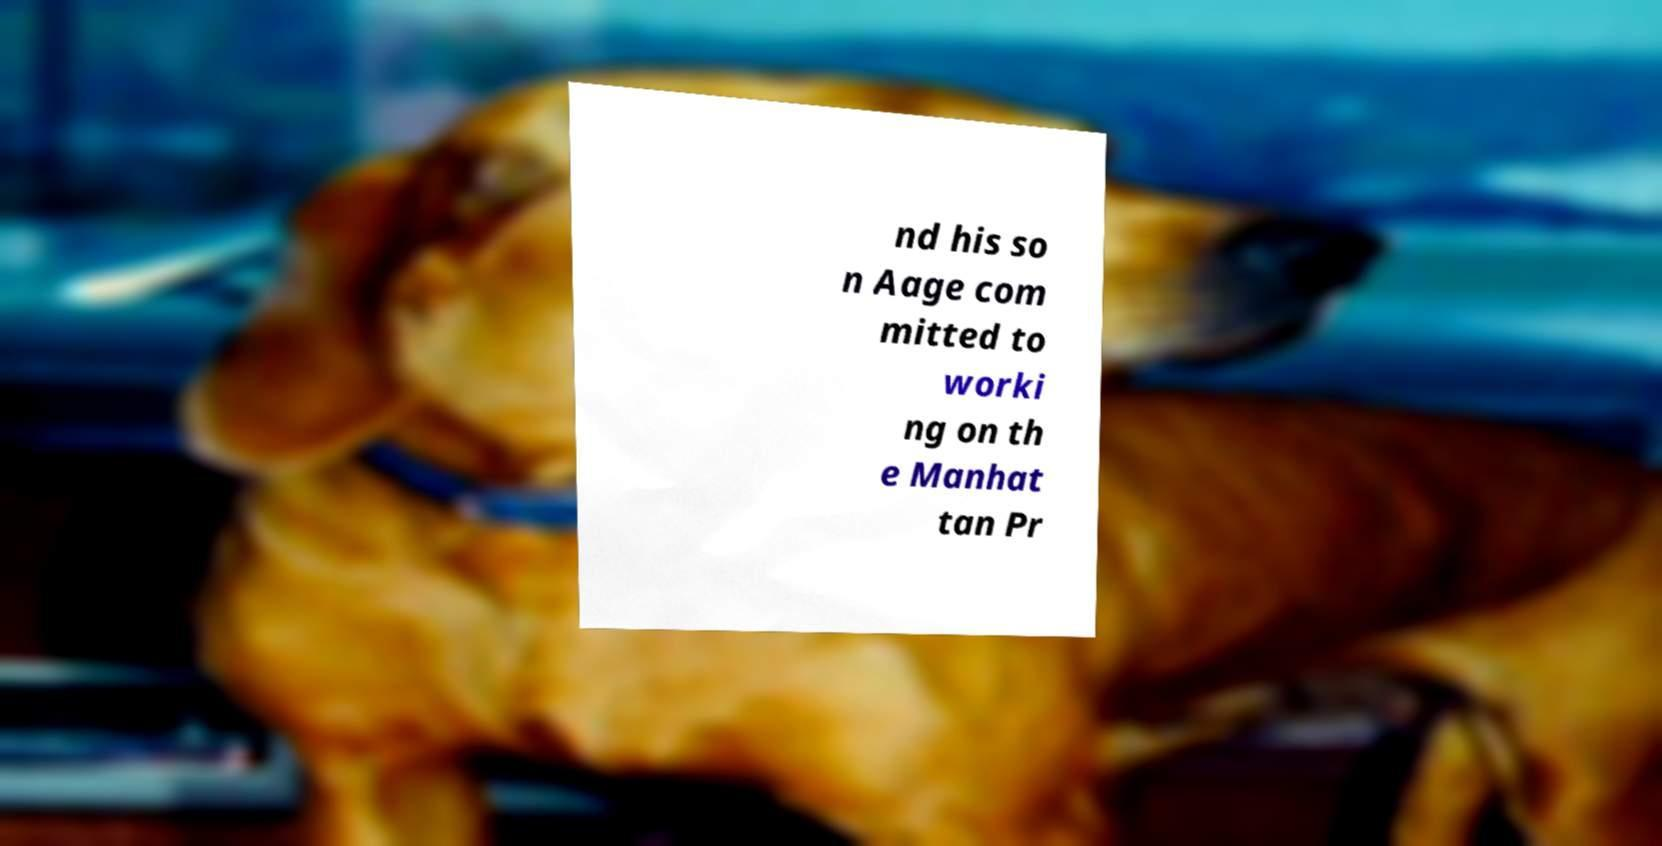There's text embedded in this image that I need extracted. Can you transcribe it verbatim? nd his so n Aage com mitted to worki ng on th e Manhat tan Pr 